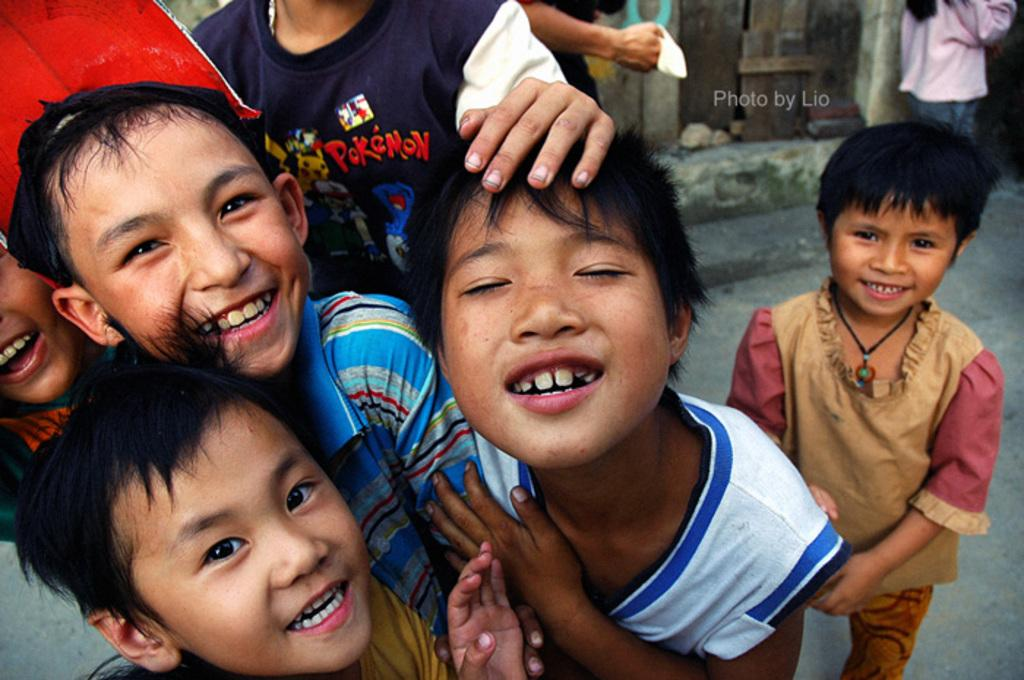Who is present in the image? There are kids in the image. What are the kids doing in the image? The kids are standing and smiling. What can be seen in the background of the image? There is a road and a wall in the background of the image. What type of pest can be seen crawling on the wall in the image? There is no pest visible on the wall in the image. Can you tell me how many wishes the kids are making in the image? There is no indication in the image that the kids are making wishes, so it cannot be determined from the picture. 